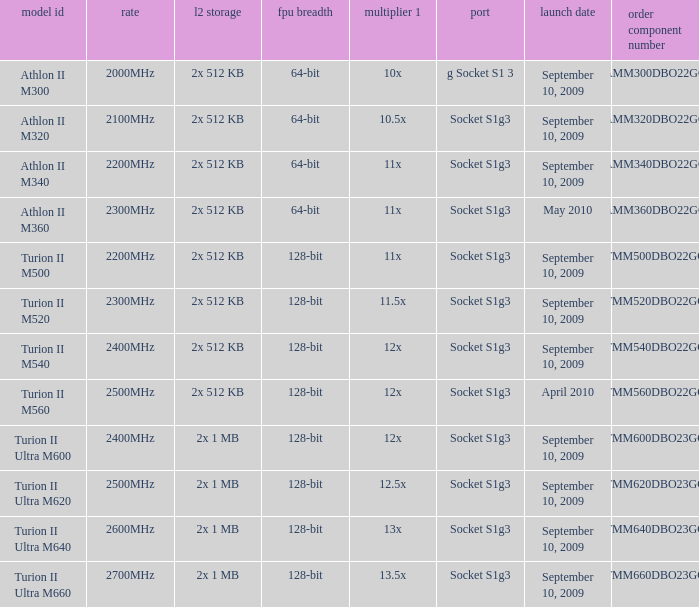What is the order part number with a 12.5x multi 1? TMM620DBO23GQ. 